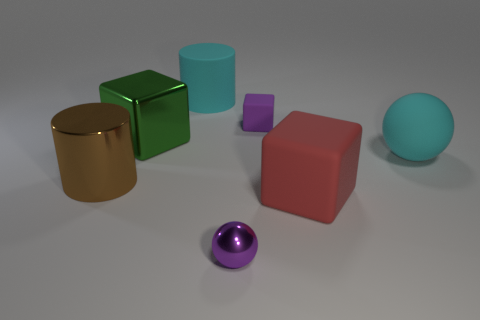Is there anything else that is the same size as the purple rubber block?
Offer a terse response. Yes. There is a block that is the same color as the small metallic sphere; what material is it?
Keep it short and to the point. Rubber. What number of large green metal cubes are on the left side of the small purple metal thing right of the large cylinder that is to the left of the cyan matte cylinder?
Your answer should be compact. 1. What material is the green cube that is the same size as the cyan cylinder?
Provide a succinct answer. Metal. Are there any metal spheres that have the same size as the green thing?
Your response must be concise. No. The small matte block is what color?
Provide a succinct answer. Purple. What color is the large shiny thing that is behind the sphere that is behind the small metal ball?
Ensure brevity in your answer.  Green. There is a big shiny thing right of the large cylinder that is left of the cyan object that is left of the large red thing; what is its shape?
Offer a terse response. Cube. What number of cyan objects have the same material as the red object?
Give a very brief answer. 2. What number of big red rubber things are behind the big cylinder that is in front of the purple matte thing?
Ensure brevity in your answer.  0. 